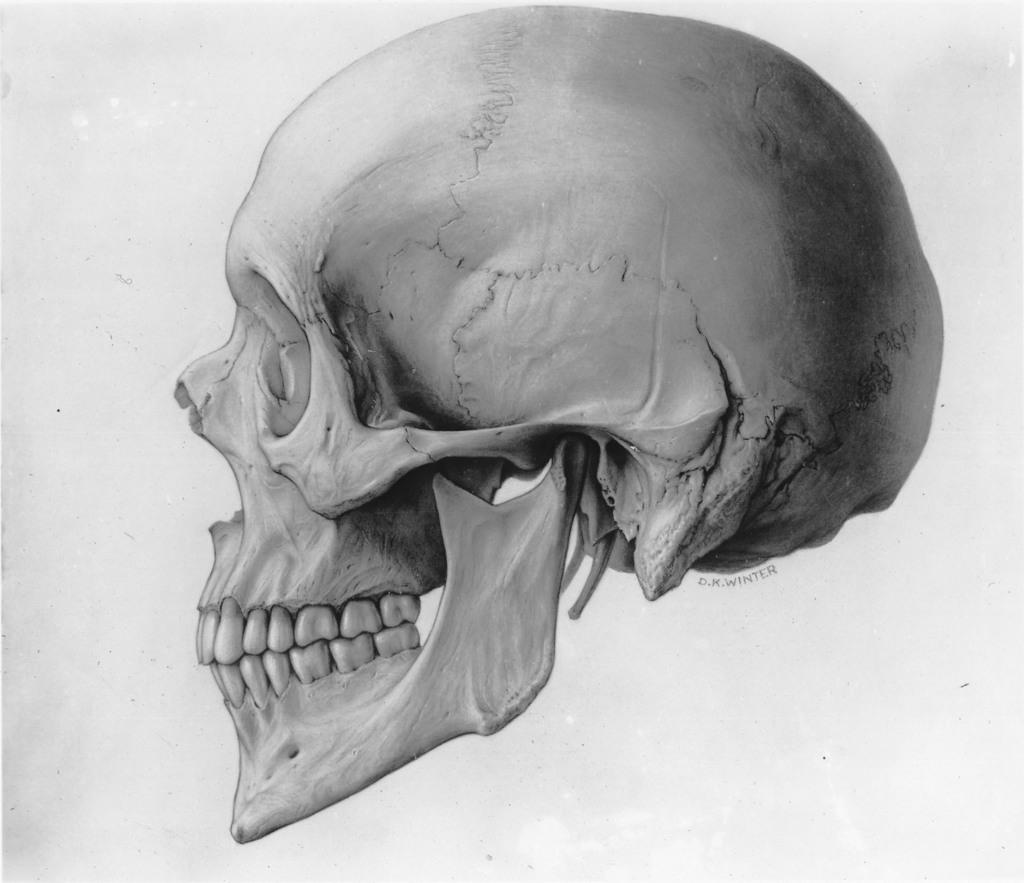What is the main subject of the image? The main subject of the image is a skull. What type of tax is being discussed in the image? There is no discussion of tax in the image, as it features a skull and no other elements. 